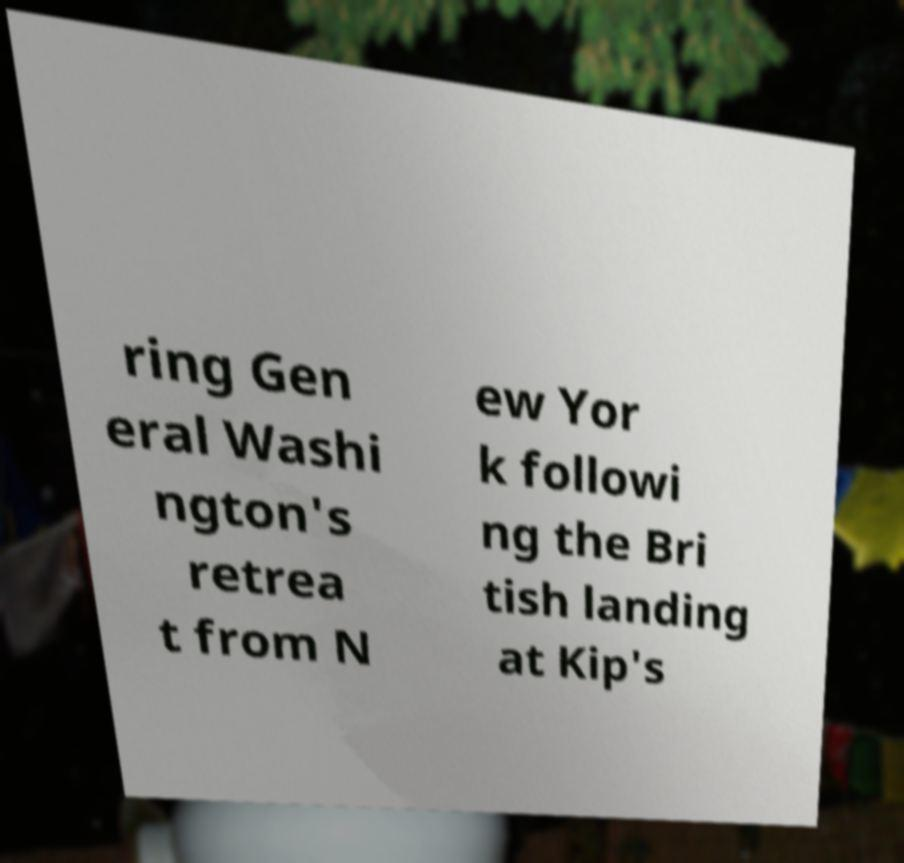Could you assist in decoding the text presented in this image and type it out clearly? ring Gen eral Washi ngton's retrea t from N ew Yor k followi ng the Bri tish landing at Kip's 